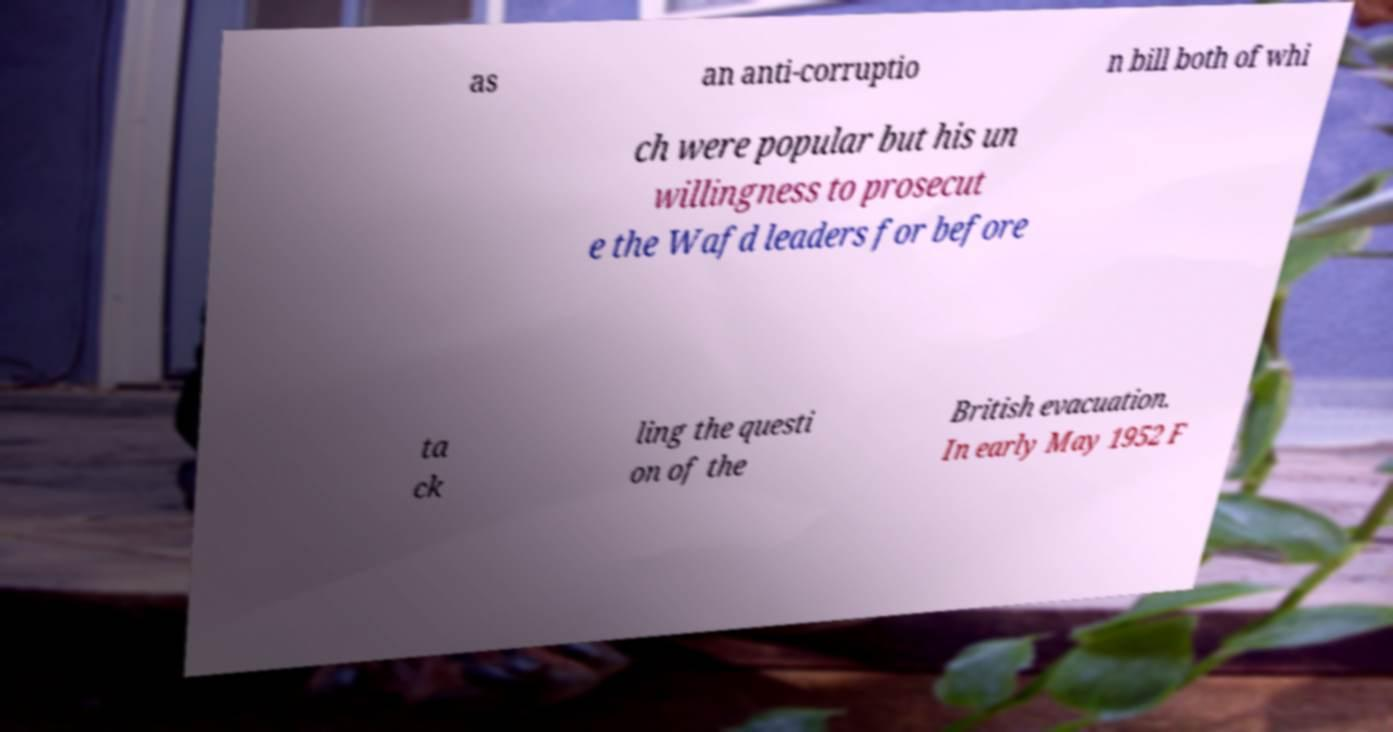I need the written content from this picture converted into text. Can you do that? as an anti-corruptio n bill both of whi ch were popular but his un willingness to prosecut e the Wafd leaders for before ta ck ling the questi on of the British evacuation. In early May 1952 F 